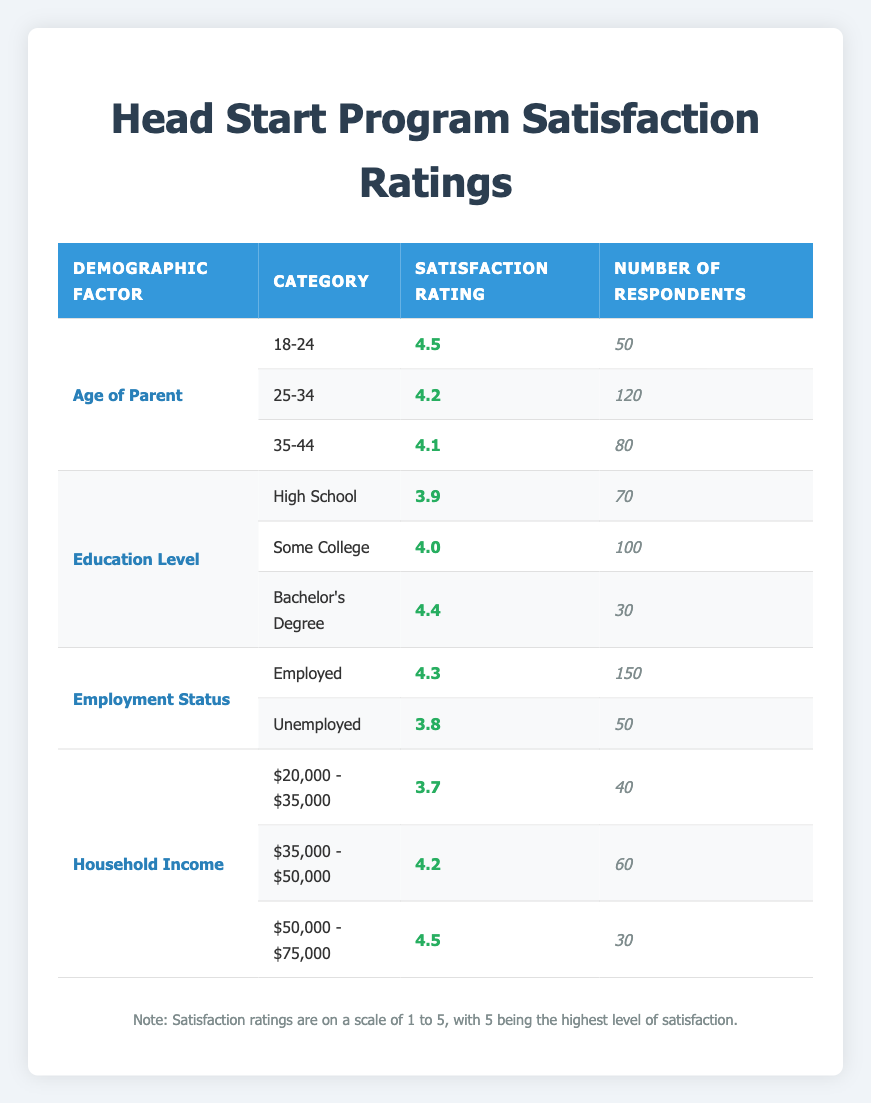What is the satisfaction rating for parents aged 18-24? The satisfaction rating for parents aged 18-24 is found in the "Age of Parent" section of the table, specifically in the row where the category is "18-24." The value is 4.5.
Answer: 4.5 Which demographic group has the lowest satisfaction rating? To find this, we check the satisfaction ratings for each demographic factor. The lowest satisfaction rating is in the "Household Income" category for the range "$20,000 - $35,000," which is 3.7.
Answer: $20,000 - $35,000 What is the average satisfaction rating for parents with some college education? The satisfaction rating for the "Some College" category is 4.0. Since it is the only value, the average is also 4.0.
Answer: 4.0 What is the total number of respondents from the employed group? The total number of respondents from the "Employed" group is listed in the "Employment Status" section under the "Employed" category, which states there are 150 respondents.
Answer: 150 Is the satisfaction rating higher for parents with a bachelor's degree compared to unemployed parents? The satisfaction rating for parents with a bachelor's degree is 4.4, while the satisfaction rating for unemployed parents is 3.8. Since 4.4 > 3.8, the statement is true.
Answer: Yes Which age group has the second-highest satisfaction rating? The age groups listed are 18-24 (4.5), 25-34 (4.2), and 35-44 (4.1). The second-highest satisfaction rating is for the group 25-34, which is 4.2.
Answer: 25-34 How does the satisfaction rating for parents with high school education compare to those earning $35,000 - $50,000? The satisfaction rating for parents with high school education is 3.9, and for those earning $35,000 - $50,000, it is 4.2. Since 4.2 > 3.9, the income group has a higher rating.
Answer: $35,000 - $50,000 has a higher rating What is the difference in satisfaction ratings between the lowest and highest income categories listed? The lowest income category "$20,000 - $35,000" has a satisfaction rating of 3.7, while "$50,000 - $75,000" has a rating of 4.5. To find the difference, subtract 3.7 from 4.5, resulting in 0.8.
Answer: 0.8 Does the average satisfaction rating for employed parents exceed 4.0? The satisfaction rating for employed parents is 4.3, which is greater than 4.0. Therefore, the statement is true.
Answer: Yes 